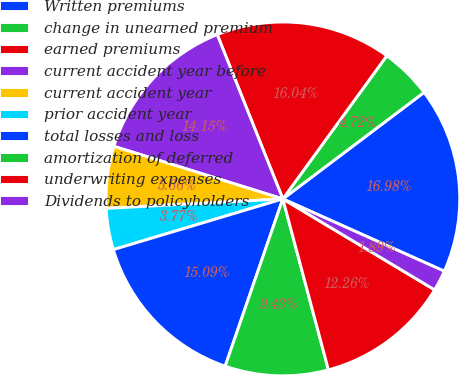Convert chart to OTSL. <chart><loc_0><loc_0><loc_500><loc_500><pie_chart><fcel>Written premiums<fcel>change in unearned premium<fcel>earned premiums<fcel>current accident year before<fcel>current accident year<fcel>prior accident year<fcel>total losses and loss<fcel>amortization of deferred<fcel>underwriting expenses<fcel>Dividends to policyholders<nl><fcel>16.98%<fcel>4.72%<fcel>16.04%<fcel>14.15%<fcel>5.66%<fcel>3.77%<fcel>15.09%<fcel>9.43%<fcel>12.26%<fcel>1.89%<nl></chart> 